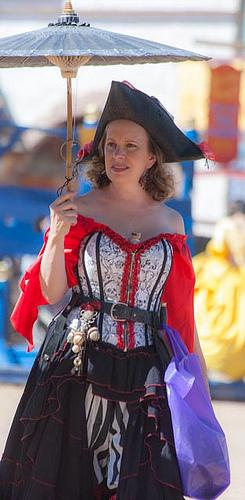Question: what is the lady dressed as?
Choices:
A. A cat.
B. A police officer.
C. A pirate.
D. A stripper.
Answer with the letter. Answer: C Question: when was this picture taken?
Choices:
A. At night.
B. Daytime.
C. At sunrise.
D. At evening.
Answer with the letter. Answer: B Question: what color are her sleeves?
Choices:
A. Purple.
B. Gold.
C. Blue.
D. Red.
Answer with the letter. Answer: D Question: what is the color of her skirt?
Choices:
A. Red.
B. White.
C. Black.
D. Green.
Answer with the letter. Answer: C 